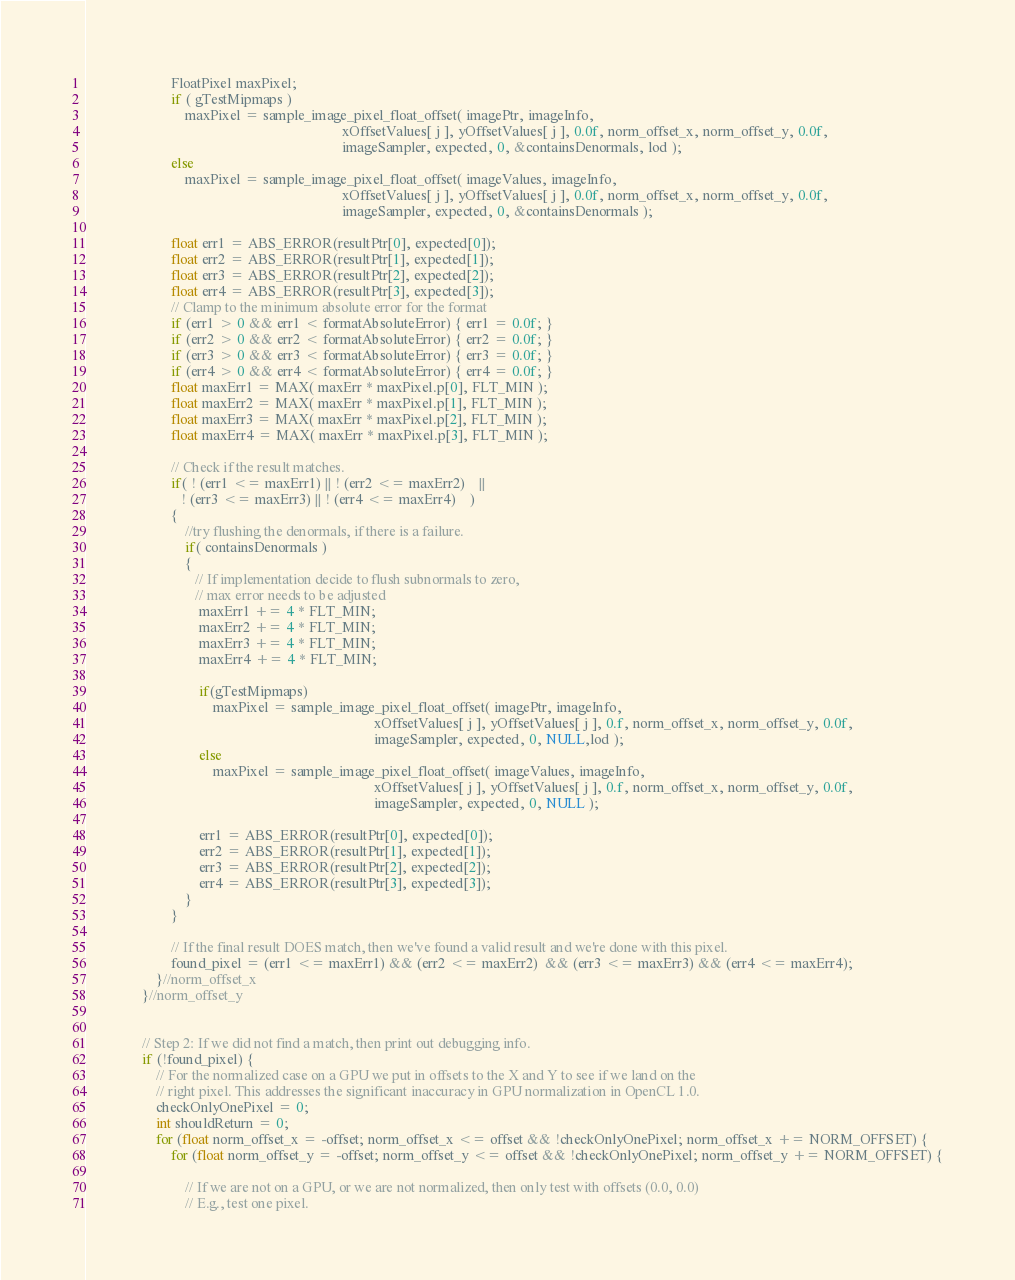<code> <loc_0><loc_0><loc_500><loc_500><_C++_>                        FloatPixel maxPixel;
                        if ( gTestMipmaps )
                            maxPixel = sample_image_pixel_float_offset( imagePtr, imageInfo,
                                                                        xOffsetValues[ j ], yOffsetValues[ j ], 0.0f, norm_offset_x, norm_offset_y, 0.0f,
                                                                        imageSampler, expected, 0, &containsDenormals, lod );
                        else
                            maxPixel = sample_image_pixel_float_offset( imageValues, imageInfo,
                                                                        xOffsetValues[ j ], yOffsetValues[ j ], 0.0f, norm_offset_x, norm_offset_y, 0.0f,
                                                                        imageSampler, expected, 0, &containsDenormals );

                        float err1 = ABS_ERROR(resultPtr[0], expected[0]);
                        float err2 = ABS_ERROR(resultPtr[1], expected[1]);
                        float err3 = ABS_ERROR(resultPtr[2], expected[2]);
                        float err4 = ABS_ERROR(resultPtr[3], expected[3]);
                        // Clamp to the minimum absolute error for the format
                        if (err1 > 0 && err1 < formatAbsoluteError) { err1 = 0.0f; }
                        if (err2 > 0 && err2 < formatAbsoluteError) { err2 = 0.0f; }
                        if (err3 > 0 && err3 < formatAbsoluteError) { err3 = 0.0f; }
                        if (err4 > 0 && err4 < formatAbsoluteError) { err4 = 0.0f; }
                        float maxErr1 = MAX( maxErr * maxPixel.p[0], FLT_MIN );
                        float maxErr2 = MAX( maxErr * maxPixel.p[1], FLT_MIN );
                        float maxErr3 = MAX( maxErr * maxPixel.p[2], FLT_MIN );
                        float maxErr4 = MAX( maxErr * maxPixel.p[3], FLT_MIN );

                        // Check if the result matches.
                        if( ! (err1 <= maxErr1) || ! (err2 <= maxErr2)    ||
                           ! (err3 <= maxErr3) || ! (err4 <= maxErr4)    )
                        {
                            //try flushing the denormals, if there is a failure.
                            if( containsDenormals )
                            {
                               // If implementation decide to flush subnormals to zero,
                               // max error needs to be adjusted
                                maxErr1 += 4 * FLT_MIN;
                                maxErr2 += 4 * FLT_MIN;
                                maxErr3 += 4 * FLT_MIN;
                                maxErr4 += 4 * FLT_MIN;

                                if(gTestMipmaps)
                                    maxPixel = sample_image_pixel_float_offset( imagePtr, imageInfo,
                                                                                 xOffsetValues[ j ], yOffsetValues[ j ], 0.f, norm_offset_x, norm_offset_y, 0.0f,
                                                                                 imageSampler, expected, 0, NULL,lod );
                                else
                                    maxPixel = sample_image_pixel_float_offset( imageValues, imageInfo,
                                                                                 xOffsetValues[ j ], yOffsetValues[ j ], 0.f, norm_offset_x, norm_offset_y, 0.0f,
                                                                                 imageSampler, expected, 0, NULL );

                                err1 = ABS_ERROR(resultPtr[0], expected[0]);
                                err2 = ABS_ERROR(resultPtr[1], expected[1]);
                                err3 = ABS_ERROR(resultPtr[2], expected[2]);
                                err4 = ABS_ERROR(resultPtr[3], expected[3]);
                            }
                        }

                        // If the final result DOES match, then we've found a valid result and we're done with this pixel.
                        found_pixel = (err1 <= maxErr1) && (err2 <= maxErr2)  && (err3 <= maxErr3) && (err4 <= maxErr4);
                    }//norm_offset_x
                }//norm_offset_y


                // Step 2: If we did not find a match, then print out debugging info.
                if (!found_pixel) {
                    // For the normalized case on a GPU we put in offsets to the X and Y to see if we land on the
                    // right pixel. This addresses the significant inaccuracy in GPU normalization in OpenCL 1.0.
                    checkOnlyOnePixel = 0;
                    int shouldReturn = 0;
                    for (float norm_offset_x = -offset; norm_offset_x <= offset && !checkOnlyOnePixel; norm_offset_x += NORM_OFFSET) {
                        for (float norm_offset_y = -offset; norm_offset_y <= offset && !checkOnlyOnePixel; norm_offset_y += NORM_OFFSET) {

                            // If we are not on a GPU, or we are not normalized, then only test with offsets (0.0, 0.0)
                            // E.g., test one pixel.</code> 